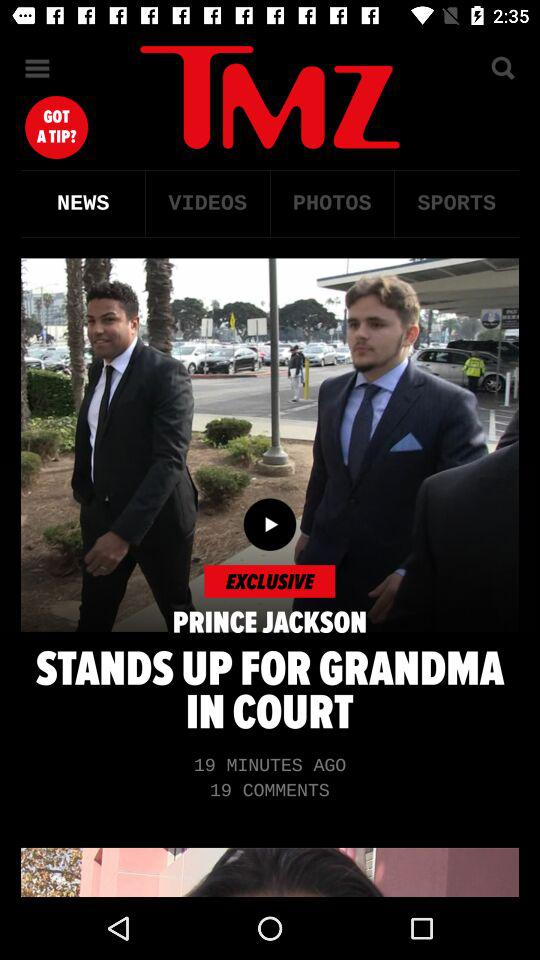Which tab is selected? The selected tab is "NEWS". 